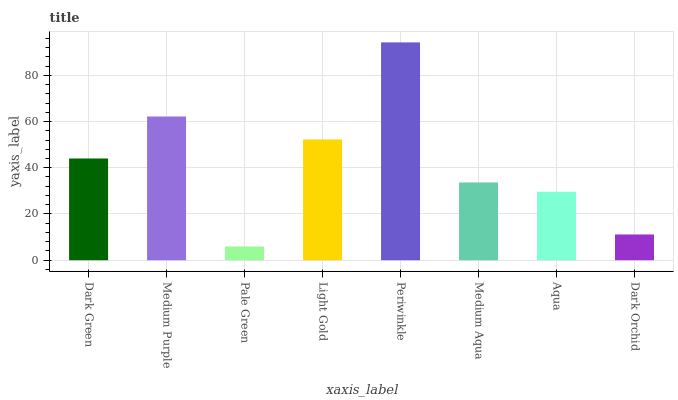Is Pale Green the minimum?
Answer yes or no. Yes. Is Periwinkle the maximum?
Answer yes or no. Yes. Is Medium Purple the minimum?
Answer yes or no. No. Is Medium Purple the maximum?
Answer yes or no. No. Is Medium Purple greater than Dark Green?
Answer yes or no. Yes. Is Dark Green less than Medium Purple?
Answer yes or no. Yes. Is Dark Green greater than Medium Purple?
Answer yes or no. No. Is Medium Purple less than Dark Green?
Answer yes or no. No. Is Dark Green the high median?
Answer yes or no. Yes. Is Medium Aqua the low median?
Answer yes or no. Yes. Is Light Gold the high median?
Answer yes or no. No. Is Periwinkle the low median?
Answer yes or no. No. 